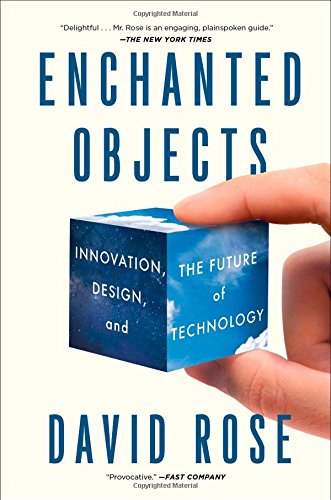Can you describe the visual design of the book's cover? The cover of 'Enchanted Objects' features a vivid blue cube that appears to be floating, symbolizing innovation and the 'magic' of technology. The cube is central to the design, suggesting the transformation of the ordinary into the extraordinary through design and technology. 